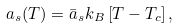<formula> <loc_0><loc_0><loc_500><loc_500>a _ { s } ( T ) = \bar { a } _ { s } k _ { B } \left [ T - T _ { c } \right ] ,</formula> 